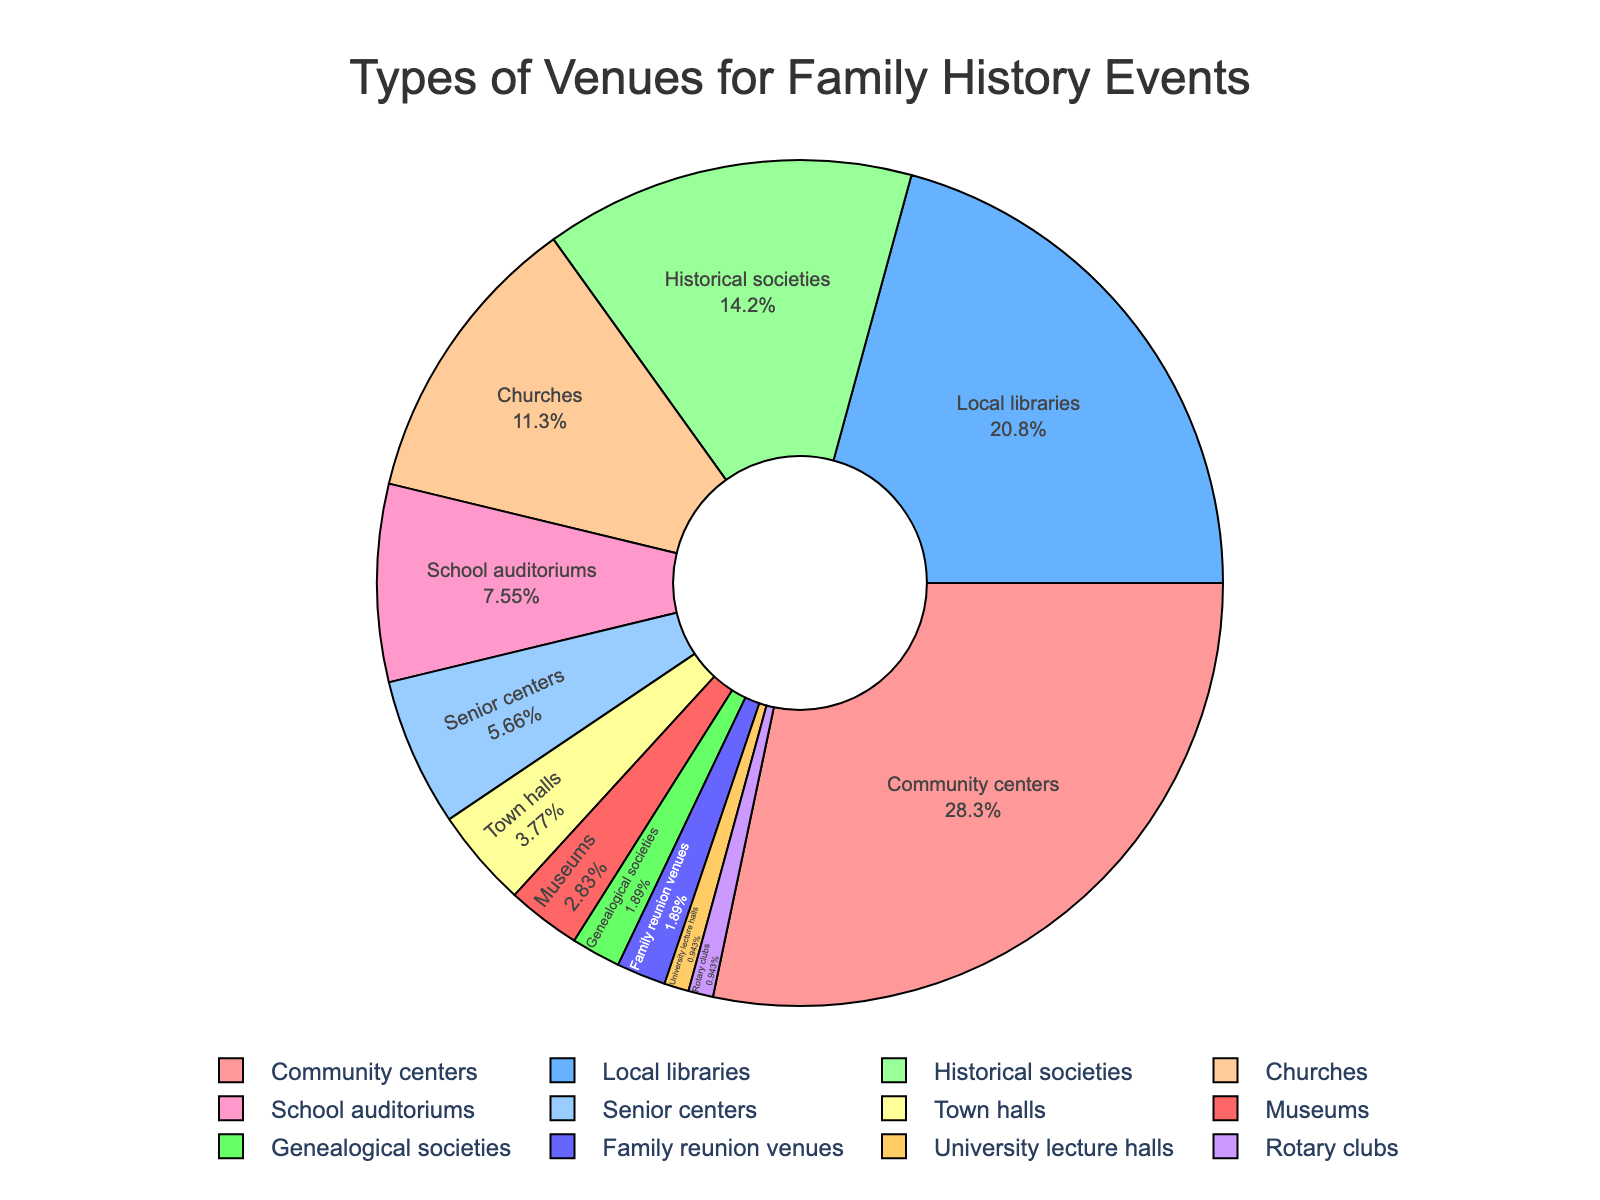What is the most common type of venue used for family history events? The figure shows a pie chart with different types of venues and their corresponding percentages. The largest segment is labeled "Community centers" with 30%.
Answer: Community centers Which type of venue is used least frequently for family history events? By examining the smallest segments in the pie chart, the two smallest segments are "University lecture halls" and "Rotary clubs", both with 1%.
Answer: University lecture halls and Rotary clubs How many types of venues collectively account for more than 60% of family history events? To find how many types account for more than 60%, sum the percentages until you exceed 60%. Three types alone surpass this: "Community centers" (30%), "Local libraries" (22%), and "Historical societies" (15%). 30% + 22% + 15% = 67%.
Answer: 3 What is the difference in percentage between the use of community centers and school auditoriums for family history events? The figures show "Community centers" at 30% and "School auditoriums" at 8%. The difference is calculated as 30% - 8%.
Answer: 22% Which two types of venues have a combined usage percentage closest to that of historical societies? "Historical societies" account for 15%. The venues "Churches" (12%) and "Senior centers" (6%) together have 12% + 6% = 18%. This is the closest combined value to 15% among the groups.
Answer: Churches and Senior centers Are museums used more frequently than genealogical societies for family history events? By examining the segments, "Museums" account for 3%, while "Genealogical societies" account for 2%. 3% > 2%.
Answer: Yes Which venue category has a middle-range percentage, neither among the highest nor among the lowest? "School auditoriums" and "Senior centers" have middle-range percentages of 8% and 6%, respectively. Of these, "School auditoriums" doesn't belong to the high nor the extremely low ends.
Answer: School auditoriums What percentage of venues account for less than 5% each? Adding the percentages for all venues less than 5%: "Town halls" (4%), "Museums" (3%), "Genealogical societies" (2%), "Family reunion venues" (2%), "University lecture halls" (1%), and "Rotary clubs" (1%). 4% + 3% + 2% + 2% + 1% + 1% = 13%.
Answer: 13% What color represents the segment for local libraries in the pie chart? The colors of each segment differ, but we can infer from the pie chart that "Local libraries" are represented by the second color in the list, which is blue.
Answer: Blue 